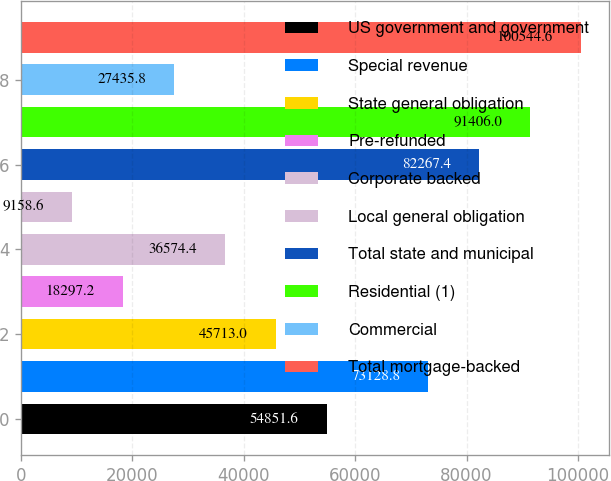<chart> <loc_0><loc_0><loc_500><loc_500><bar_chart><fcel>US government and government<fcel>Special revenue<fcel>State general obligation<fcel>Pre-refunded<fcel>Corporate backed<fcel>Local general obligation<fcel>Total state and municipal<fcel>Residential (1)<fcel>Commercial<fcel>Total mortgage-backed<nl><fcel>54851.6<fcel>73128.8<fcel>45713<fcel>18297.2<fcel>36574.4<fcel>9158.6<fcel>82267.4<fcel>91406<fcel>27435.8<fcel>100545<nl></chart> 